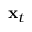Convert formula to latex. <formula><loc_0><loc_0><loc_500><loc_500>x _ { t }</formula> 